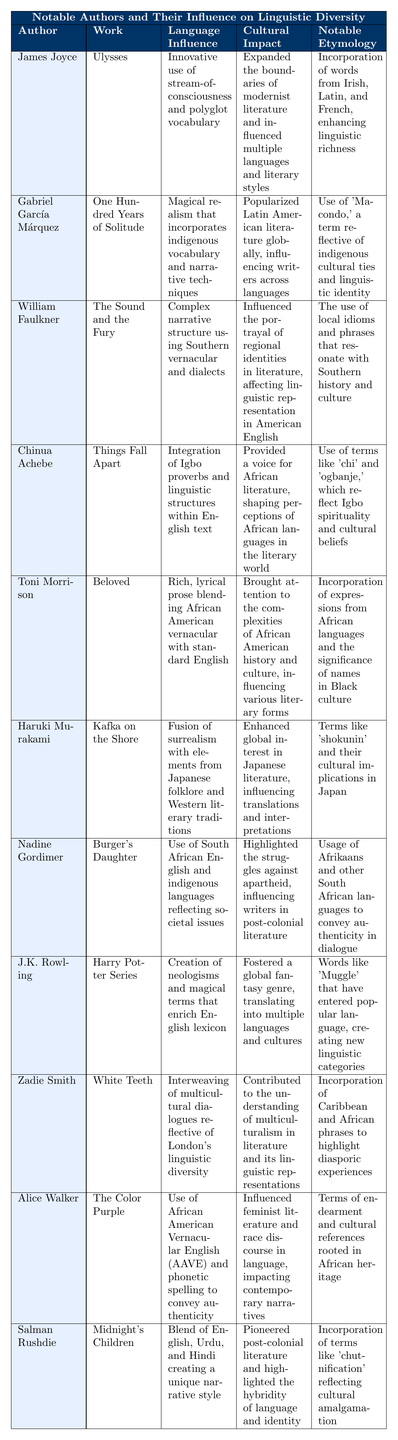What work did James Joyce write? The table lists the works associated with each author. For James Joyce, the work is "Ulysses."
Answer: Ulysses Which author's work involves "integrating Igbo proverbs"? By referring to the language influence of each author, Chinua Achebe's work "Things Fall Apart" is noted for integrating Igbo proverbs.
Answer: Chinua Achebe What language influence is attributed to Toni Morrison? The table specifies the language influence for Toni Morrison's work "Beloved" as blending African American vernacular with standard English.
Answer: Blending African American vernacular with standard English Which author is known for a unique narrative style that blends multiple languages? Looking at the table, Salman Rushdie's work "Midnight's Children" is recognized for blending English, Urdu, and Hindi.
Answer: Salman Rushdie True or False: Gabriel García Márquez's work has influenced authors globally across languages. The cultural impact of Gabriel García Márquez's work "One Hundred Years of Solitude" states it popularized Latin American literature globally, confirming the statement is true.
Answer: True What notable etymology is associated with the work of Haruki Murakami? The table lists notable etymology for Haruki Murakami’s "Kafka on the Shore," which mentions terms like 'shokunin' and their cultural implications in Japan.
Answer: Terms like 'shokunin' How many authors mentioned have works that incorporate African languages in some form? By analyzing the table, the authors who incorporate African languages are Toni Morrison, Chinua Achebe, and Alice Walker, making a total of three.
Answer: Three Which author's work is described as "magical realism that incorporates indigenous vocabulary"? The table describes Gabriel García Márquez's work "One Hundred Years of Solitude" in this way.
Answer: Gabriel García Márquez What is the cultural impact of J.K. Rowling's work? The table outlines J.K. Rowling's work "Harry Potter Series" as fostering a global fantasy genre, translated into multiple languages and cultures, displaying significant cultural impact.
Answer: Fostered a global fantasy genre How does the language influence of Nadine Gordimer reflect societal issues? Nadine Gordimer's work "Burger's Daughter" is noted for using South African English and indigenous languages to reflect societal issues.
Answer: Using South African English and indigenous languages Identify the author whose work features a lyrical prose style merged with African American vernacular. The table indicates that Toni Morrison’s work "Beloved" features this lyrical prose style.
Answer: Toni Morrison 